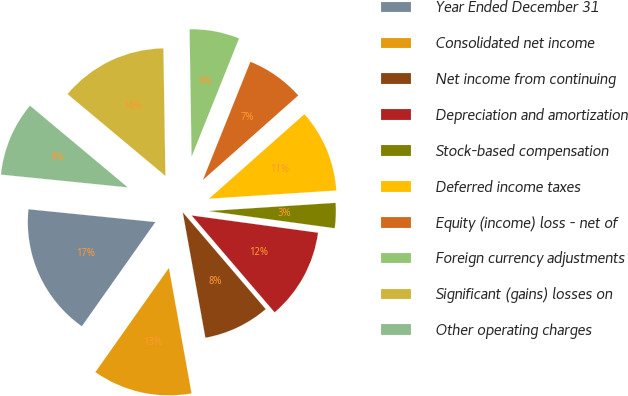Convert chart. <chart><loc_0><loc_0><loc_500><loc_500><pie_chart><fcel>Year Ended December 31<fcel>Consolidated net income<fcel>Net income from continuing<fcel>Depreciation and amortization<fcel>Stock-based compensation<fcel>Deferred income taxes<fcel>Equity (income) loss - net of<fcel>Foreign currency adjustments<fcel>Significant (gains) losses on<fcel>Other operating charges<nl><fcel>16.82%<fcel>12.62%<fcel>8.43%<fcel>11.57%<fcel>3.18%<fcel>10.52%<fcel>7.38%<fcel>6.33%<fcel>13.67%<fcel>9.48%<nl></chart> 